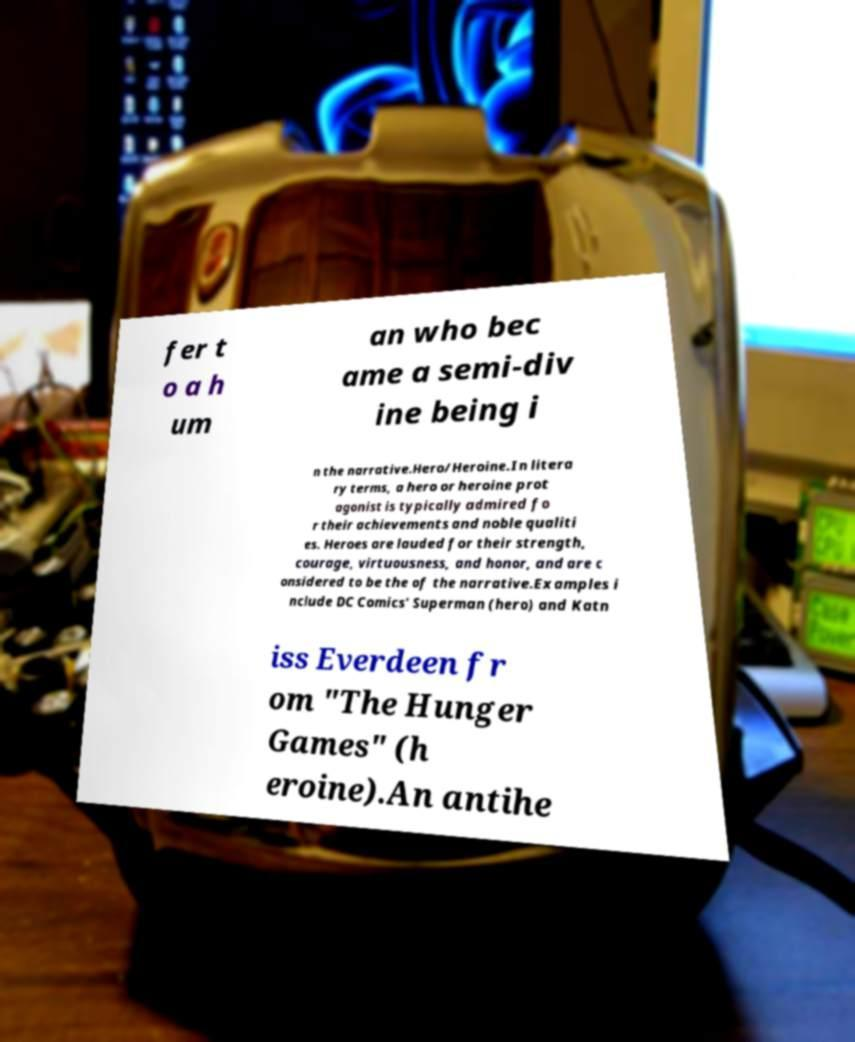Can you read and provide the text displayed in the image?This photo seems to have some interesting text. Can you extract and type it out for me? fer t o a h um an who bec ame a semi-div ine being i n the narrative.Hero/Heroine.In litera ry terms, a hero or heroine prot agonist is typically admired fo r their achievements and noble qualiti es. Heroes are lauded for their strength, courage, virtuousness, and honor, and are c onsidered to be the of the narrative.Examples i nclude DC Comics' Superman (hero) and Katn iss Everdeen fr om "The Hunger Games" (h eroine).An antihe 